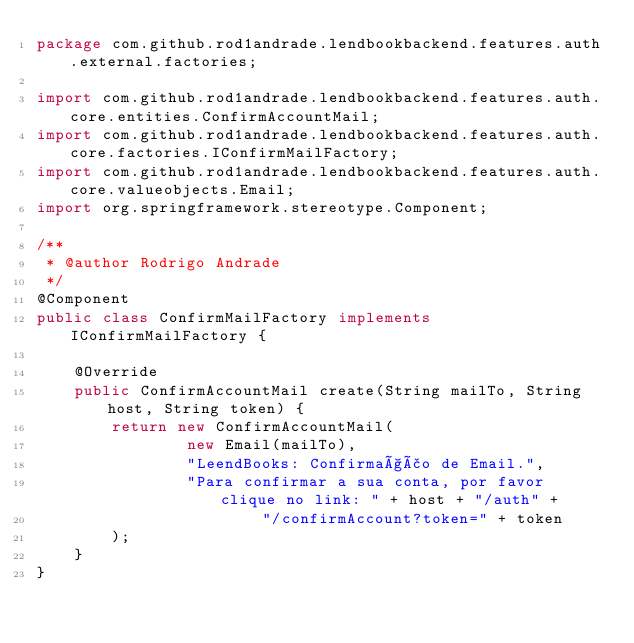Convert code to text. <code><loc_0><loc_0><loc_500><loc_500><_Java_>package com.github.rod1andrade.lendbookbackend.features.auth.external.factories;

import com.github.rod1andrade.lendbookbackend.features.auth.core.entities.ConfirmAccountMail;
import com.github.rod1andrade.lendbookbackend.features.auth.core.factories.IConfirmMailFactory;
import com.github.rod1andrade.lendbookbackend.features.auth.core.valueobjects.Email;
import org.springframework.stereotype.Component;

/**
 * @author Rodrigo Andrade
 */
@Component
public class ConfirmMailFactory implements IConfirmMailFactory {

    @Override
    public ConfirmAccountMail create(String mailTo, String host, String token) {
        return new ConfirmAccountMail(
                new Email(mailTo),
                "LeendBooks: Confirmação de Email.",
                "Para confirmar a sua conta, por favor clique no link: " + host + "/auth" +
                        "/confirmAccount?token=" + token
        );
    }
}
</code> 